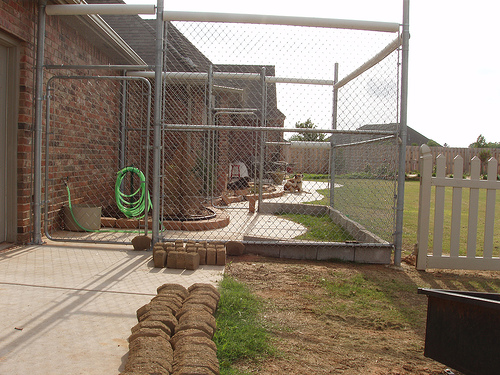<image>
Can you confirm if the hose is behind the fence? Yes. From this viewpoint, the hose is positioned behind the fence, with the fence partially or fully occluding the hose. 